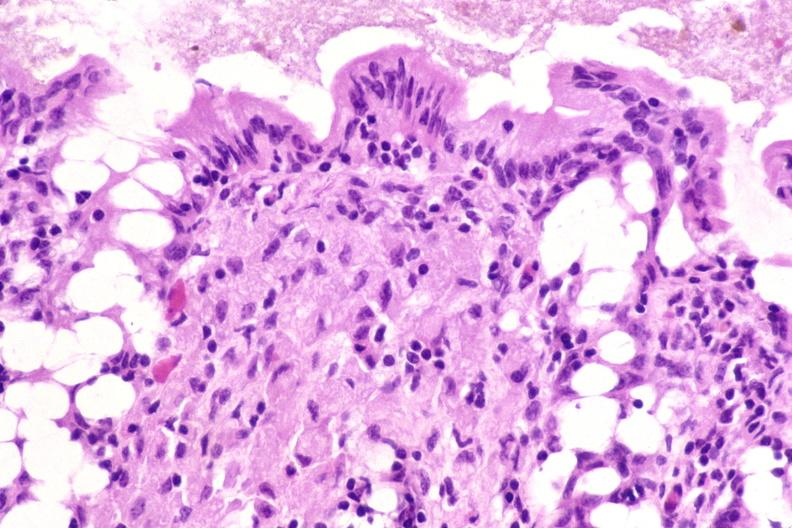what stain?
Answer the question using a single word or phrase. Colon biopsy, mycobacterium avium-intracellularae, acid 